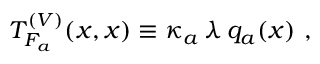Convert formula to latex. <formula><loc_0><loc_0><loc_500><loc_500>T _ { F _ { a } } ^ { ( V ) } ( x , x ) \equiv \kappa _ { a } \, \lambda \, q _ { a } ( x ) \ ,</formula> 